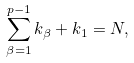<formula> <loc_0><loc_0><loc_500><loc_500>\sum _ { \beta = 1 } ^ { p - 1 } k _ { \beta } + k _ { 1 } = N ,</formula> 